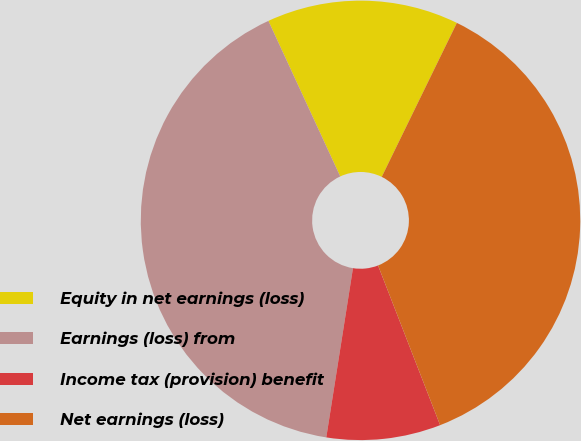Convert chart. <chart><loc_0><loc_0><loc_500><loc_500><pie_chart><fcel>Equity in net earnings (loss)<fcel>Earnings (loss) from<fcel>Income tax (provision) benefit<fcel>Net earnings (loss)<nl><fcel>14.11%<fcel>40.62%<fcel>8.39%<fcel>36.87%<nl></chart> 